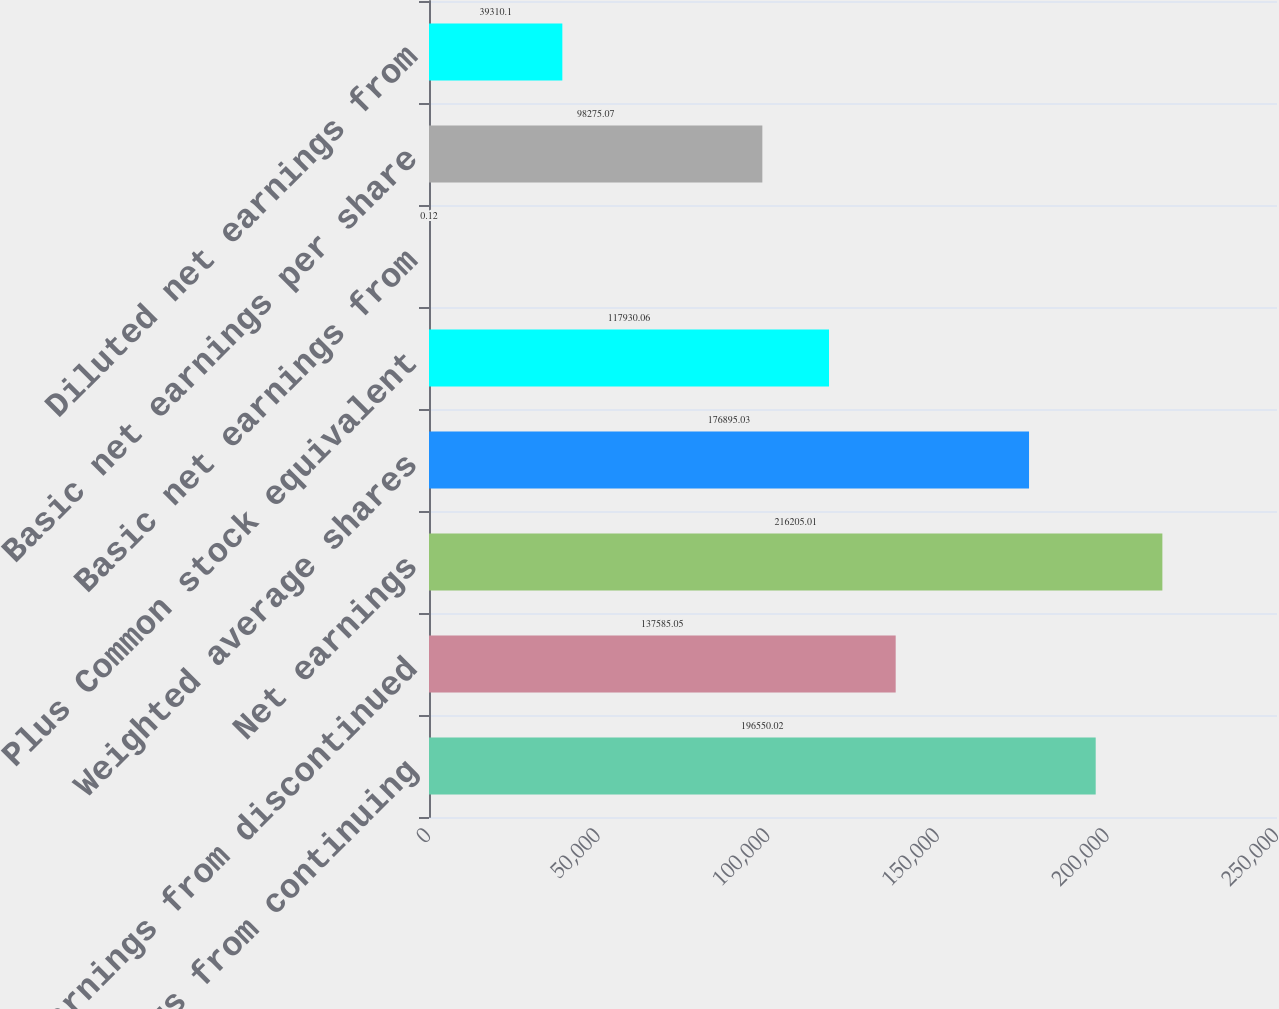<chart> <loc_0><loc_0><loc_500><loc_500><bar_chart><fcel>Net earnings from continuing<fcel>Net earnings from discontinued<fcel>Net earnings<fcel>Weighted average shares<fcel>Plus Common stock equivalent<fcel>Basic net earnings from<fcel>Basic net earnings per share<fcel>Diluted net earnings from<nl><fcel>196550<fcel>137585<fcel>216205<fcel>176895<fcel>117930<fcel>0.12<fcel>98275.1<fcel>39310.1<nl></chart> 